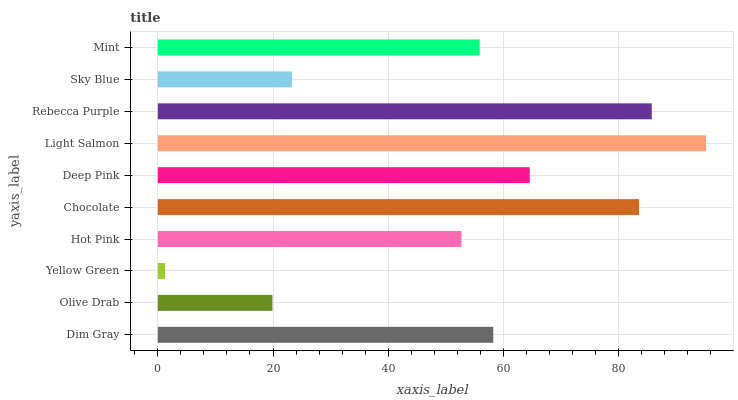Is Yellow Green the minimum?
Answer yes or no. Yes. Is Light Salmon the maximum?
Answer yes or no. Yes. Is Olive Drab the minimum?
Answer yes or no. No. Is Olive Drab the maximum?
Answer yes or no. No. Is Dim Gray greater than Olive Drab?
Answer yes or no. Yes. Is Olive Drab less than Dim Gray?
Answer yes or no. Yes. Is Olive Drab greater than Dim Gray?
Answer yes or no. No. Is Dim Gray less than Olive Drab?
Answer yes or no. No. Is Dim Gray the high median?
Answer yes or no. Yes. Is Mint the low median?
Answer yes or no. Yes. Is Olive Drab the high median?
Answer yes or no. No. Is Sky Blue the low median?
Answer yes or no. No. 